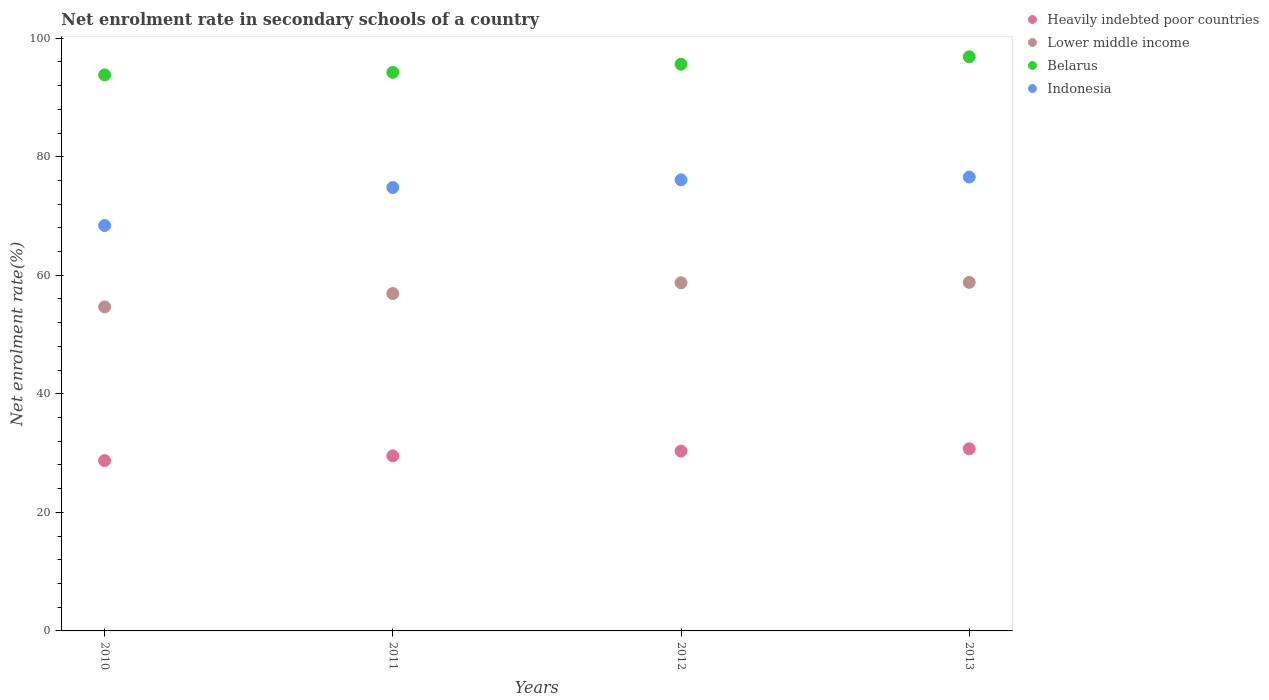How many different coloured dotlines are there?
Give a very brief answer. 4. What is the net enrolment rate in secondary schools in Lower middle income in 2013?
Your answer should be compact. 58.8. Across all years, what is the maximum net enrolment rate in secondary schools in Indonesia?
Give a very brief answer. 76.57. Across all years, what is the minimum net enrolment rate in secondary schools in Indonesia?
Give a very brief answer. 68.39. In which year was the net enrolment rate in secondary schools in Indonesia maximum?
Provide a succinct answer. 2013. What is the total net enrolment rate in secondary schools in Heavily indebted poor countries in the graph?
Make the answer very short. 119.33. What is the difference between the net enrolment rate in secondary schools in Belarus in 2010 and that in 2011?
Offer a very short reply. -0.43. What is the difference between the net enrolment rate in secondary schools in Heavily indebted poor countries in 2011 and the net enrolment rate in secondary schools in Lower middle income in 2010?
Your answer should be compact. -25.14. What is the average net enrolment rate in secondary schools in Belarus per year?
Offer a very short reply. 95.13. In the year 2013, what is the difference between the net enrolment rate in secondary schools in Belarus and net enrolment rate in secondary schools in Lower middle income?
Make the answer very short. 38.06. What is the ratio of the net enrolment rate in secondary schools in Lower middle income in 2010 to that in 2013?
Give a very brief answer. 0.93. What is the difference between the highest and the second highest net enrolment rate in secondary schools in Lower middle income?
Your response must be concise. 0.06. What is the difference between the highest and the lowest net enrolment rate in secondary schools in Indonesia?
Your answer should be compact. 8.18. Is the sum of the net enrolment rate in secondary schools in Indonesia in 2011 and 2013 greater than the maximum net enrolment rate in secondary schools in Heavily indebted poor countries across all years?
Your answer should be compact. Yes. Is it the case that in every year, the sum of the net enrolment rate in secondary schools in Heavily indebted poor countries and net enrolment rate in secondary schools in Belarus  is greater than the sum of net enrolment rate in secondary schools in Lower middle income and net enrolment rate in secondary schools in Indonesia?
Provide a short and direct response. Yes. Is it the case that in every year, the sum of the net enrolment rate in secondary schools in Lower middle income and net enrolment rate in secondary schools in Indonesia  is greater than the net enrolment rate in secondary schools in Belarus?
Your answer should be compact. Yes. Does the net enrolment rate in secondary schools in Lower middle income monotonically increase over the years?
Make the answer very short. Yes. Is the net enrolment rate in secondary schools in Indonesia strictly greater than the net enrolment rate in secondary schools in Lower middle income over the years?
Give a very brief answer. Yes. Is the net enrolment rate in secondary schools in Lower middle income strictly less than the net enrolment rate in secondary schools in Heavily indebted poor countries over the years?
Offer a very short reply. No. How many dotlines are there?
Provide a succinct answer. 4. What is the difference between two consecutive major ticks on the Y-axis?
Provide a short and direct response. 20. Does the graph contain any zero values?
Provide a short and direct response. No. Does the graph contain grids?
Your answer should be compact. No. How many legend labels are there?
Provide a short and direct response. 4. How are the legend labels stacked?
Your answer should be very brief. Vertical. What is the title of the graph?
Offer a very short reply. Net enrolment rate in secondary schools of a country. What is the label or title of the X-axis?
Offer a terse response. Years. What is the label or title of the Y-axis?
Ensure brevity in your answer.  Net enrolment rate(%). What is the Net enrolment rate(%) in Heavily indebted poor countries in 2010?
Keep it short and to the point. 28.74. What is the Net enrolment rate(%) in Lower middle income in 2010?
Your answer should be very brief. 54.67. What is the Net enrolment rate(%) of Belarus in 2010?
Make the answer very short. 93.8. What is the Net enrolment rate(%) in Indonesia in 2010?
Provide a succinct answer. 68.39. What is the Net enrolment rate(%) in Heavily indebted poor countries in 2011?
Ensure brevity in your answer.  29.53. What is the Net enrolment rate(%) in Lower middle income in 2011?
Provide a succinct answer. 56.92. What is the Net enrolment rate(%) of Belarus in 2011?
Offer a very short reply. 94.23. What is the Net enrolment rate(%) of Indonesia in 2011?
Offer a terse response. 74.81. What is the Net enrolment rate(%) of Heavily indebted poor countries in 2012?
Offer a very short reply. 30.33. What is the Net enrolment rate(%) in Lower middle income in 2012?
Provide a short and direct response. 58.74. What is the Net enrolment rate(%) in Belarus in 2012?
Your answer should be very brief. 95.61. What is the Net enrolment rate(%) of Indonesia in 2012?
Your answer should be very brief. 76.1. What is the Net enrolment rate(%) in Heavily indebted poor countries in 2013?
Your response must be concise. 30.73. What is the Net enrolment rate(%) in Lower middle income in 2013?
Ensure brevity in your answer.  58.8. What is the Net enrolment rate(%) of Belarus in 2013?
Offer a terse response. 96.86. What is the Net enrolment rate(%) in Indonesia in 2013?
Provide a succinct answer. 76.57. Across all years, what is the maximum Net enrolment rate(%) of Heavily indebted poor countries?
Offer a very short reply. 30.73. Across all years, what is the maximum Net enrolment rate(%) of Lower middle income?
Offer a very short reply. 58.8. Across all years, what is the maximum Net enrolment rate(%) in Belarus?
Provide a short and direct response. 96.86. Across all years, what is the maximum Net enrolment rate(%) of Indonesia?
Your answer should be very brief. 76.57. Across all years, what is the minimum Net enrolment rate(%) of Heavily indebted poor countries?
Your answer should be very brief. 28.74. Across all years, what is the minimum Net enrolment rate(%) in Lower middle income?
Offer a very short reply. 54.67. Across all years, what is the minimum Net enrolment rate(%) of Belarus?
Offer a terse response. 93.8. Across all years, what is the minimum Net enrolment rate(%) of Indonesia?
Provide a succinct answer. 68.39. What is the total Net enrolment rate(%) of Heavily indebted poor countries in the graph?
Provide a short and direct response. 119.33. What is the total Net enrolment rate(%) in Lower middle income in the graph?
Your response must be concise. 229.12. What is the total Net enrolment rate(%) of Belarus in the graph?
Your response must be concise. 380.5. What is the total Net enrolment rate(%) of Indonesia in the graph?
Your answer should be compact. 295.87. What is the difference between the Net enrolment rate(%) in Heavily indebted poor countries in 2010 and that in 2011?
Ensure brevity in your answer.  -0.79. What is the difference between the Net enrolment rate(%) of Lower middle income in 2010 and that in 2011?
Your answer should be compact. -2.25. What is the difference between the Net enrolment rate(%) in Belarus in 2010 and that in 2011?
Your response must be concise. -0.43. What is the difference between the Net enrolment rate(%) in Indonesia in 2010 and that in 2011?
Make the answer very short. -6.41. What is the difference between the Net enrolment rate(%) of Heavily indebted poor countries in 2010 and that in 2012?
Provide a short and direct response. -1.6. What is the difference between the Net enrolment rate(%) of Lower middle income in 2010 and that in 2012?
Ensure brevity in your answer.  -4.07. What is the difference between the Net enrolment rate(%) in Belarus in 2010 and that in 2012?
Your response must be concise. -1.81. What is the difference between the Net enrolment rate(%) of Indonesia in 2010 and that in 2012?
Keep it short and to the point. -7.71. What is the difference between the Net enrolment rate(%) of Heavily indebted poor countries in 2010 and that in 2013?
Make the answer very short. -1.99. What is the difference between the Net enrolment rate(%) in Lower middle income in 2010 and that in 2013?
Offer a very short reply. -4.14. What is the difference between the Net enrolment rate(%) of Belarus in 2010 and that in 2013?
Ensure brevity in your answer.  -3.06. What is the difference between the Net enrolment rate(%) of Indonesia in 2010 and that in 2013?
Ensure brevity in your answer.  -8.18. What is the difference between the Net enrolment rate(%) in Heavily indebted poor countries in 2011 and that in 2012?
Make the answer very short. -0.8. What is the difference between the Net enrolment rate(%) of Lower middle income in 2011 and that in 2012?
Your answer should be compact. -1.82. What is the difference between the Net enrolment rate(%) of Belarus in 2011 and that in 2012?
Offer a terse response. -1.38. What is the difference between the Net enrolment rate(%) in Indonesia in 2011 and that in 2012?
Ensure brevity in your answer.  -1.29. What is the difference between the Net enrolment rate(%) of Heavily indebted poor countries in 2011 and that in 2013?
Keep it short and to the point. -1.2. What is the difference between the Net enrolment rate(%) of Lower middle income in 2011 and that in 2013?
Your answer should be compact. -1.89. What is the difference between the Net enrolment rate(%) in Belarus in 2011 and that in 2013?
Provide a short and direct response. -2.63. What is the difference between the Net enrolment rate(%) in Indonesia in 2011 and that in 2013?
Offer a very short reply. -1.76. What is the difference between the Net enrolment rate(%) in Heavily indebted poor countries in 2012 and that in 2013?
Your answer should be very brief. -0.39. What is the difference between the Net enrolment rate(%) in Lower middle income in 2012 and that in 2013?
Your answer should be compact. -0.06. What is the difference between the Net enrolment rate(%) of Belarus in 2012 and that in 2013?
Offer a terse response. -1.25. What is the difference between the Net enrolment rate(%) in Indonesia in 2012 and that in 2013?
Offer a very short reply. -0.47. What is the difference between the Net enrolment rate(%) of Heavily indebted poor countries in 2010 and the Net enrolment rate(%) of Lower middle income in 2011?
Your answer should be very brief. -28.18. What is the difference between the Net enrolment rate(%) of Heavily indebted poor countries in 2010 and the Net enrolment rate(%) of Belarus in 2011?
Provide a short and direct response. -65.49. What is the difference between the Net enrolment rate(%) in Heavily indebted poor countries in 2010 and the Net enrolment rate(%) in Indonesia in 2011?
Offer a very short reply. -46.07. What is the difference between the Net enrolment rate(%) in Lower middle income in 2010 and the Net enrolment rate(%) in Belarus in 2011?
Provide a succinct answer. -39.56. What is the difference between the Net enrolment rate(%) in Lower middle income in 2010 and the Net enrolment rate(%) in Indonesia in 2011?
Keep it short and to the point. -20.14. What is the difference between the Net enrolment rate(%) of Belarus in 2010 and the Net enrolment rate(%) of Indonesia in 2011?
Offer a very short reply. 18.99. What is the difference between the Net enrolment rate(%) in Heavily indebted poor countries in 2010 and the Net enrolment rate(%) in Lower middle income in 2012?
Ensure brevity in your answer.  -30. What is the difference between the Net enrolment rate(%) of Heavily indebted poor countries in 2010 and the Net enrolment rate(%) of Belarus in 2012?
Your response must be concise. -66.87. What is the difference between the Net enrolment rate(%) of Heavily indebted poor countries in 2010 and the Net enrolment rate(%) of Indonesia in 2012?
Keep it short and to the point. -47.36. What is the difference between the Net enrolment rate(%) in Lower middle income in 2010 and the Net enrolment rate(%) in Belarus in 2012?
Offer a terse response. -40.94. What is the difference between the Net enrolment rate(%) in Lower middle income in 2010 and the Net enrolment rate(%) in Indonesia in 2012?
Offer a terse response. -21.44. What is the difference between the Net enrolment rate(%) of Belarus in 2010 and the Net enrolment rate(%) of Indonesia in 2012?
Your answer should be compact. 17.7. What is the difference between the Net enrolment rate(%) of Heavily indebted poor countries in 2010 and the Net enrolment rate(%) of Lower middle income in 2013?
Offer a terse response. -30.07. What is the difference between the Net enrolment rate(%) in Heavily indebted poor countries in 2010 and the Net enrolment rate(%) in Belarus in 2013?
Make the answer very short. -68.13. What is the difference between the Net enrolment rate(%) in Heavily indebted poor countries in 2010 and the Net enrolment rate(%) in Indonesia in 2013?
Offer a terse response. -47.83. What is the difference between the Net enrolment rate(%) of Lower middle income in 2010 and the Net enrolment rate(%) of Belarus in 2013?
Offer a terse response. -42.2. What is the difference between the Net enrolment rate(%) in Lower middle income in 2010 and the Net enrolment rate(%) in Indonesia in 2013?
Provide a succinct answer. -21.9. What is the difference between the Net enrolment rate(%) of Belarus in 2010 and the Net enrolment rate(%) of Indonesia in 2013?
Offer a terse response. 17.23. What is the difference between the Net enrolment rate(%) in Heavily indebted poor countries in 2011 and the Net enrolment rate(%) in Lower middle income in 2012?
Keep it short and to the point. -29.21. What is the difference between the Net enrolment rate(%) in Heavily indebted poor countries in 2011 and the Net enrolment rate(%) in Belarus in 2012?
Offer a terse response. -66.08. What is the difference between the Net enrolment rate(%) of Heavily indebted poor countries in 2011 and the Net enrolment rate(%) of Indonesia in 2012?
Offer a terse response. -46.57. What is the difference between the Net enrolment rate(%) in Lower middle income in 2011 and the Net enrolment rate(%) in Belarus in 2012?
Offer a very short reply. -38.69. What is the difference between the Net enrolment rate(%) in Lower middle income in 2011 and the Net enrolment rate(%) in Indonesia in 2012?
Make the answer very short. -19.18. What is the difference between the Net enrolment rate(%) in Belarus in 2011 and the Net enrolment rate(%) in Indonesia in 2012?
Provide a short and direct response. 18.13. What is the difference between the Net enrolment rate(%) in Heavily indebted poor countries in 2011 and the Net enrolment rate(%) in Lower middle income in 2013?
Offer a very short reply. -29.27. What is the difference between the Net enrolment rate(%) in Heavily indebted poor countries in 2011 and the Net enrolment rate(%) in Belarus in 2013?
Your response must be concise. -67.33. What is the difference between the Net enrolment rate(%) in Heavily indebted poor countries in 2011 and the Net enrolment rate(%) in Indonesia in 2013?
Provide a short and direct response. -47.04. What is the difference between the Net enrolment rate(%) of Lower middle income in 2011 and the Net enrolment rate(%) of Belarus in 2013?
Your response must be concise. -39.95. What is the difference between the Net enrolment rate(%) in Lower middle income in 2011 and the Net enrolment rate(%) in Indonesia in 2013?
Keep it short and to the point. -19.65. What is the difference between the Net enrolment rate(%) in Belarus in 2011 and the Net enrolment rate(%) in Indonesia in 2013?
Keep it short and to the point. 17.66. What is the difference between the Net enrolment rate(%) of Heavily indebted poor countries in 2012 and the Net enrolment rate(%) of Lower middle income in 2013?
Offer a very short reply. -28.47. What is the difference between the Net enrolment rate(%) of Heavily indebted poor countries in 2012 and the Net enrolment rate(%) of Belarus in 2013?
Provide a short and direct response. -66.53. What is the difference between the Net enrolment rate(%) of Heavily indebted poor countries in 2012 and the Net enrolment rate(%) of Indonesia in 2013?
Provide a succinct answer. -46.23. What is the difference between the Net enrolment rate(%) in Lower middle income in 2012 and the Net enrolment rate(%) in Belarus in 2013?
Your response must be concise. -38.13. What is the difference between the Net enrolment rate(%) in Lower middle income in 2012 and the Net enrolment rate(%) in Indonesia in 2013?
Provide a short and direct response. -17.83. What is the difference between the Net enrolment rate(%) in Belarus in 2012 and the Net enrolment rate(%) in Indonesia in 2013?
Your answer should be very brief. 19.04. What is the average Net enrolment rate(%) of Heavily indebted poor countries per year?
Offer a terse response. 29.83. What is the average Net enrolment rate(%) of Lower middle income per year?
Provide a succinct answer. 57.28. What is the average Net enrolment rate(%) in Belarus per year?
Give a very brief answer. 95.13. What is the average Net enrolment rate(%) of Indonesia per year?
Keep it short and to the point. 73.97. In the year 2010, what is the difference between the Net enrolment rate(%) in Heavily indebted poor countries and Net enrolment rate(%) in Lower middle income?
Give a very brief answer. -25.93. In the year 2010, what is the difference between the Net enrolment rate(%) of Heavily indebted poor countries and Net enrolment rate(%) of Belarus?
Your response must be concise. -65.06. In the year 2010, what is the difference between the Net enrolment rate(%) of Heavily indebted poor countries and Net enrolment rate(%) of Indonesia?
Make the answer very short. -39.66. In the year 2010, what is the difference between the Net enrolment rate(%) in Lower middle income and Net enrolment rate(%) in Belarus?
Give a very brief answer. -39.14. In the year 2010, what is the difference between the Net enrolment rate(%) of Lower middle income and Net enrolment rate(%) of Indonesia?
Your response must be concise. -13.73. In the year 2010, what is the difference between the Net enrolment rate(%) of Belarus and Net enrolment rate(%) of Indonesia?
Provide a short and direct response. 25.41. In the year 2011, what is the difference between the Net enrolment rate(%) of Heavily indebted poor countries and Net enrolment rate(%) of Lower middle income?
Ensure brevity in your answer.  -27.39. In the year 2011, what is the difference between the Net enrolment rate(%) of Heavily indebted poor countries and Net enrolment rate(%) of Belarus?
Offer a terse response. -64.7. In the year 2011, what is the difference between the Net enrolment rate(%) in Heavily indebted poor countries and Net enrolment rate(%) in Indonesia?
Your answer should be very brief. -45.28. In the year 2011, what is the difference between the Net enrolment rate(%) in Lower middle income and Net enrolment rate(%) in Belarus?
Offer a very short reply. -37.31. In the year 2011, what is the difference between the Net enrolment rate(%) of Lower middle income and Net enrolment rate(%) of Indonesia?
Give a very brief answer. -17.89. In the year 2011, what is the difference between the Net enrolment rate(%) in Belarus and Net enrolment rate(%) in Indonesia?
Provide a succinct answer. 19.42. In the year 2012, what is the difference between the Net enrolment rate(%) of Heavily indebted poor countries and Net enrolment rate(%) of Lower middle income?
Give a very brief answer. -28.4. In the year 2012, what is the difference between the Net enrolment rate(%) of Heavily indebted poor countries and Net enrolment rate(%) of Belarus?
Provide a short and direct response. -65.27. In the year 2012, what is the difference between the Net enrolment rate(%) in Heavily indebted poor countries and Net enrolment rate(%) in Indonesia?
Provide a succinct answer. -45.77. In the year 2012, what is the difference between the Net enrolment rate(%) of Lower middle income and Net enrolment rate(%) of Belarus?
Make the answer very short. -36.87. In the year 2012, what is the difference between the Net enrolment rate(%) in Lower middle income and Net enrolment rate(%) in Indonesia?
Ensure brevity in your answer.  -17.36. In the year 2012, what is the difference between the Net enrolment rate(%) of Belarus and Net enrolment rate(%) of Indonesia?
Provide a succinct answer. 19.51. In the year 2013, what is the difference between the Net enrolment rate(%) of Heavily indebted poor countries and Net enrolment rate(%) of Lower middle income?
Provide a succinct answer. -28.07. In the year 2013, what is the difference between the Net enrolment rate(%) in Heavily indebted poor countries and Net enrolment rate(%) in Belarus?
Keep it short and to the point. -66.13. In the year 2013, what is the difference between the Net enrolment rate(%) of Heavily indebted poor countries and Net enrolment rate(%) of Indonesia?
Offer a very short reply. -45.84. In the year 2013, what is the difference between the Net enrolment rate(%) in Lower middle income and Net enrolment rate(%) in Belarus?
Ensure brevity in your answer.  -38.06. In the year 2013, what is the difference between the Net enrolment rate(%) in Lower middle income and Net enrolment rate(%) in Indonesia?
Offer a very short reply. -17.77. In the year 2013, what is the difference between the Net enrolment rate(%) in Belarus and Net enrolment rate(%) in Indonesia?
Provide a short and direct response. 20.29. What is the ratio of the Net enrolment rate(%) in Heavily indebted poor countries in 2010 to that in 2011?
Your answer should be very brief. 0.97. What is the ratio of the Net enrolment rate(%) of Lower middle income in 2010 to that in 2011?
Give a very brief answer. 0.96. What is the ratio of the Net enrolment rate(%) of Indonesia in 2010 to that in 2011?
Your answer should be compact. 0.91. What is the ratio of the Net enrolment rate(%) in Heavily indebted poor countries in 2010 to that in 2012?
Make the answer very short. 0.95. What is the ratio of the Net enrolment rate(%) in Lower middle income in 2010 to that in 2012?
Provide a short and direct response. 0.93. What is the ratio of the Net enrolment rate(%) of Belarus in 2010 to that in 2012?
Provide a short and direct response. 0.98. What is the ratio of the Net enrolment rate(%) in Indonesia in 2010 to that in 2012?
Ensure brevity in your answer.  0.9. What is the ratio of the Net enrolment rate(%) in Heavily indebted poor countries in 2010 to that in 2013?
Your response must be concise. 0.94. What is the ratio of the Net enrolment rate(%) of Lower middle income in 2010 to that in 2013?
Give a very brief answer. 0.93. What is the ratio of the Net enrolment rate(%) of Belarus in 2010 to that in 2013?
Make the answer very short. 0.97. What is the ratio of the Net enrolment rate(%) of Indonesia in 2010 to that in 2013?
Your response must be concise. 0.89. What is the ratio of the Net enrolment rate(%) in Heavily indebted poor countries in 2011 to that in 2012?
Offer a very short reply. 0.97. What is the ratio of the Net enrolment rate(%) in Belarus in 2011 to that in 2012?
Offer a terse response. 0.99. What is the ratio of the Net enrolment rate(%) in Lower middle income in 2011 to that in 2013?
Provide a short and direct response. 0.97. What is the ratio of the Net enrolment rate(%) of Belarus in 2011 to that in 2013?
Ensure brevity in your answer.  0.97. What is the ratio of the Net enrolment rate(%) in Heavily indebted poor countries in 2012 to that in 2013?
Ensure brevity in your answer.  0.99. What is the ratio of the Net enrolment rate(%) of Lower middle income in 2012 to that in 2013?
Offer a terse response. 1. What is the ratio of the Net enrolment rate(%) in Belarus in 2012 to that in 2013?
Your answer should be very brief. 0.99. What is the difference between the highest and the second highest Net enrolment rate(%) in Heavily indebted poor countries?
Ensure brevity in your answer.  0.39. What is the difference between the highest and the second highest Net enrolment rate(%) in Lower middle income?
Give a very brief answer. 0.06. What is the difference between the highest and the second highest Net enrolment rate(%) in Belarus?
Keep it short and to the point. 1.25. What is the difference between the highest and the second highest Net enrolment rate(%) in Indonesia?
Provide a short and direct response. 0.47. What is the difference between the highest and the lowest Net enrolment rate(%) in Heavily indebted poor countries?
Make the answer very short. 1.99. What is the difference between the highest and the lowest Net enrolment rate(%) in Lower middle income?
Offer a terse response. 4.14. What is the difference between the highest and the lowest Net enrolment rate(%) of Belarus?
Keep it short and to the point. 3.06. What is the difference between the highest and the lowest Net enrolment rate(%) of Indonesia?
Keep it short and to the point. 8.18. 